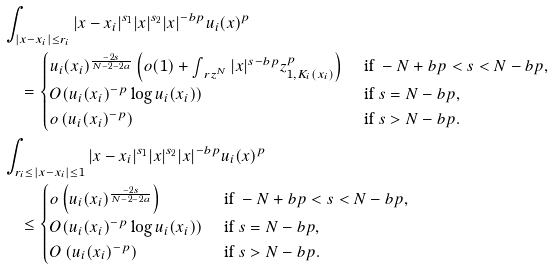Convert formula to latex. <formula><loc_0><loc_0><loc_500><loc_500>& \int _ { | x - x _ { i } | \leq r _ { i } } | x - x _ { i } | ^ { s _ { 1 } } | x | ^ { s _ { 2 } } | x | ^ { - b p } u _ { i } ( x ) ^ { p } \\ & \quad = \begin{cases} u _ { i } ( x _ { i } ) ^ { \frac { - 2 s } { N - 2 - 2 a } } \left ( o ( 1 ) + \int _ { \ r z ^ { N } } | x | ^ { s - b p } z _ { 1 , K _ { i } ( x _ { i } ) } ^ { p } \right ) & \text { if } - N + b p < s < N - b p , \\ O ( u _ { i } ( x _ { i } ) ^ { - p } \log u _ { i } ( x _ { i } ) ) & \text { if } s = N - b p , \\ o \left ( u _ { i } ( x _ { i } ) ^ { - p } \right ) & \text { if } s > N - b p . \end{cases} \\ & \int _ { r _ { i } \leq | x - x _ { i } | \leq 1 } | x - x _ { i } | ^ { s _ { 1 } } | x | ^ { s _ { 2 } } | x | ^ { - b p } u _ { i } ( x ) ^ { p } \\ & \quad \leq \begin{cases} o \left ( u _ { i } ( x _ { i } ) ^ { \frac { - 2 s } { N - 2 - 2 a } } \right ) & \text { if } - N + b p < s < N - b p , \\ O ( u _ { i } ( x _ { i } ) ^ { - p } \log u _ { i } ( x _ { i } ) ) & \text { if } s = N - b p , \\ O \left ( u _ { i } ( x _ { i } ) ^ { - p } \right ) & \text { if } s > N - b p . \end{cases}</formula> 